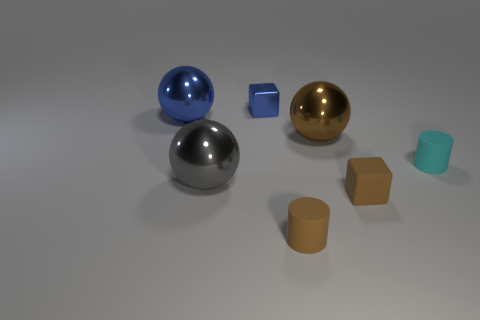There is a large object that is the same color as the tiny metallic thing; what material is it?
Offer a very short reply. Metal. What number of tiny matte things are behind the blue shiny block?
Make the answer very short. 0. What is the color of the other small rubber thing that is the same shape as the small blue object?
Your answer should be compact. Brown. What number of matte things are big blue objects or large gray things?
Keep it short and to the point. 0. Is there a tiny metallic object to the right of the metal thing to the right of the tiny matte thing in front of the brown matte block?
Provide a succinct answer. No. The rubber cube is what color?
Ensure brevity in your answer.  Brown. There is a tiny brown object that is right of the large brown object; is it the same shape as the small blue object?
Your answer should be very brief. Yes. How many things are either gray shiny spheres or brown things behind the small cyan rubber cylinder?
Offer a very short reply. 2. Does the small cube behind the big blue sphere have the same material as the big brown object?
Your response must be concise. Yes. The large thing that is right of the cube behind the tiny cyan matte cylinder is made of what material?
Make the answer very short. Metal. 